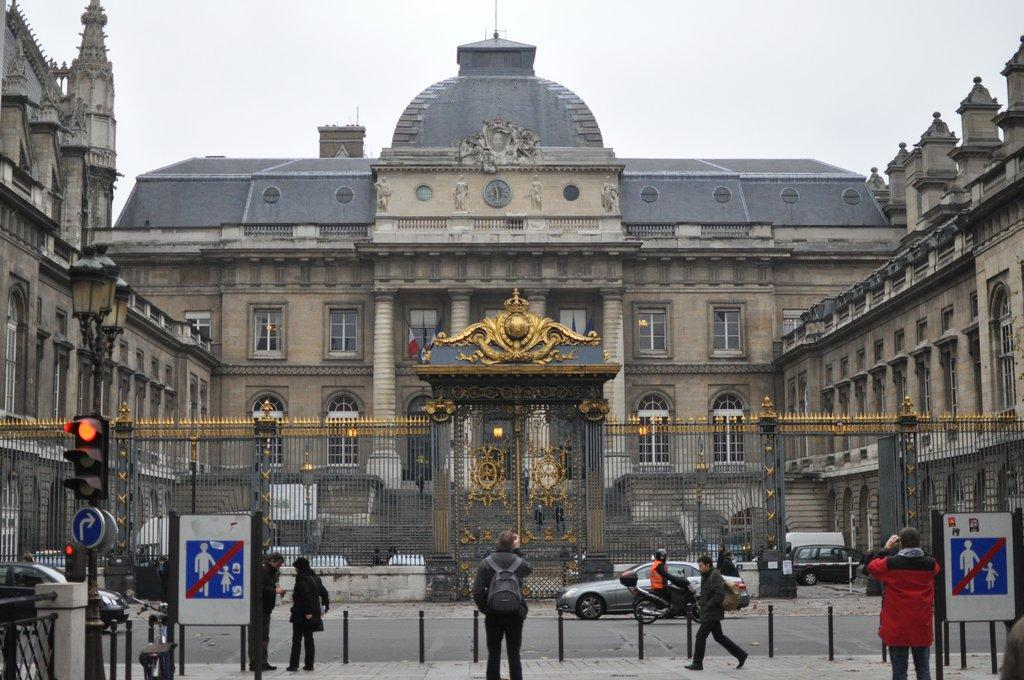What are the people in the image doing? The people in the image are walking on the footpath. What is separating the people from the palace? The people are behind a fence. What can be seen in the background of the image? There is a palace in the background. What is happening in front of the palace? Vehicles are moving in front of the palace. What part of the natural environment is visible in the image? The sky is visible above the palace. What type of celery is being used to decorate the palace in the image? There is no celery present in the image, and it is not being used to decorate the palace. What historical event is depicted in the image? There is no historical event depicted in the image; it shows people walking on a footpath, a palace in the background, and vehicles moving in front of the palace. 